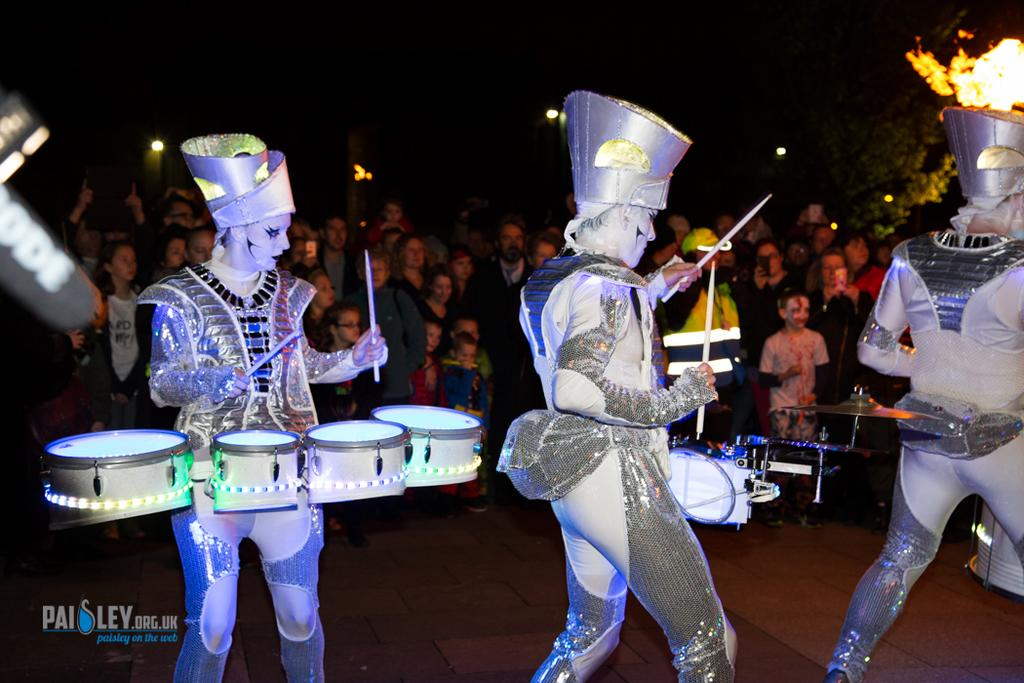What are the dancers doing in the image? The dancers are performing in the image. What instruments are the dancers using during their performance? The dancers are using drums in the image. How are the dancers dressed during their performance? The dancers are wearing different costumes in the image. Can you describe the audience in the image? There are people watching the performance in the background of the image. Where is the performance taking place? The performance is taking place on a stage. What type of scarecrow can be seen smiling in the image? There is no scarecrow present in the image, and therefore no such activity can be observed. How many oranges are being used by the dancers during their performance? There are no oranges visible in the image; the dancers are using drums instead. 